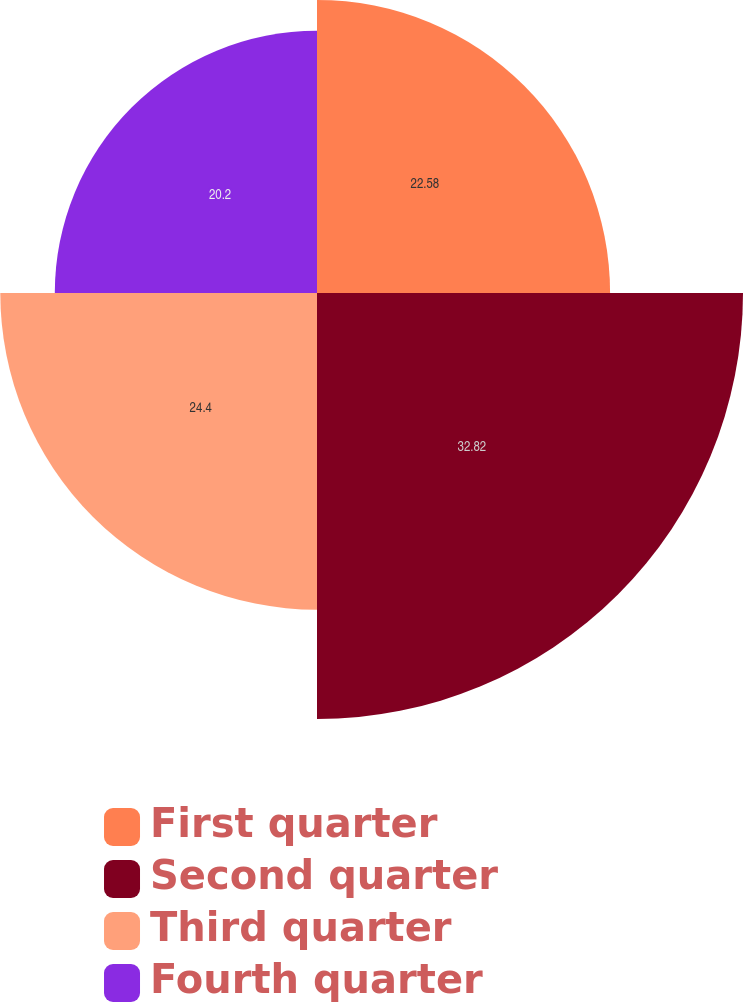<chart> <loc_0><loc_0><loc_500><loc_500><pie_chart><fcel>First quarter<fcel>Second quarter<fcel>Third quarter<fcel>Fourth quarter<nl><fcel>22.58%<fcel>32.82%<fcel>24.4%<fcel>20.2%<nl></chart> 